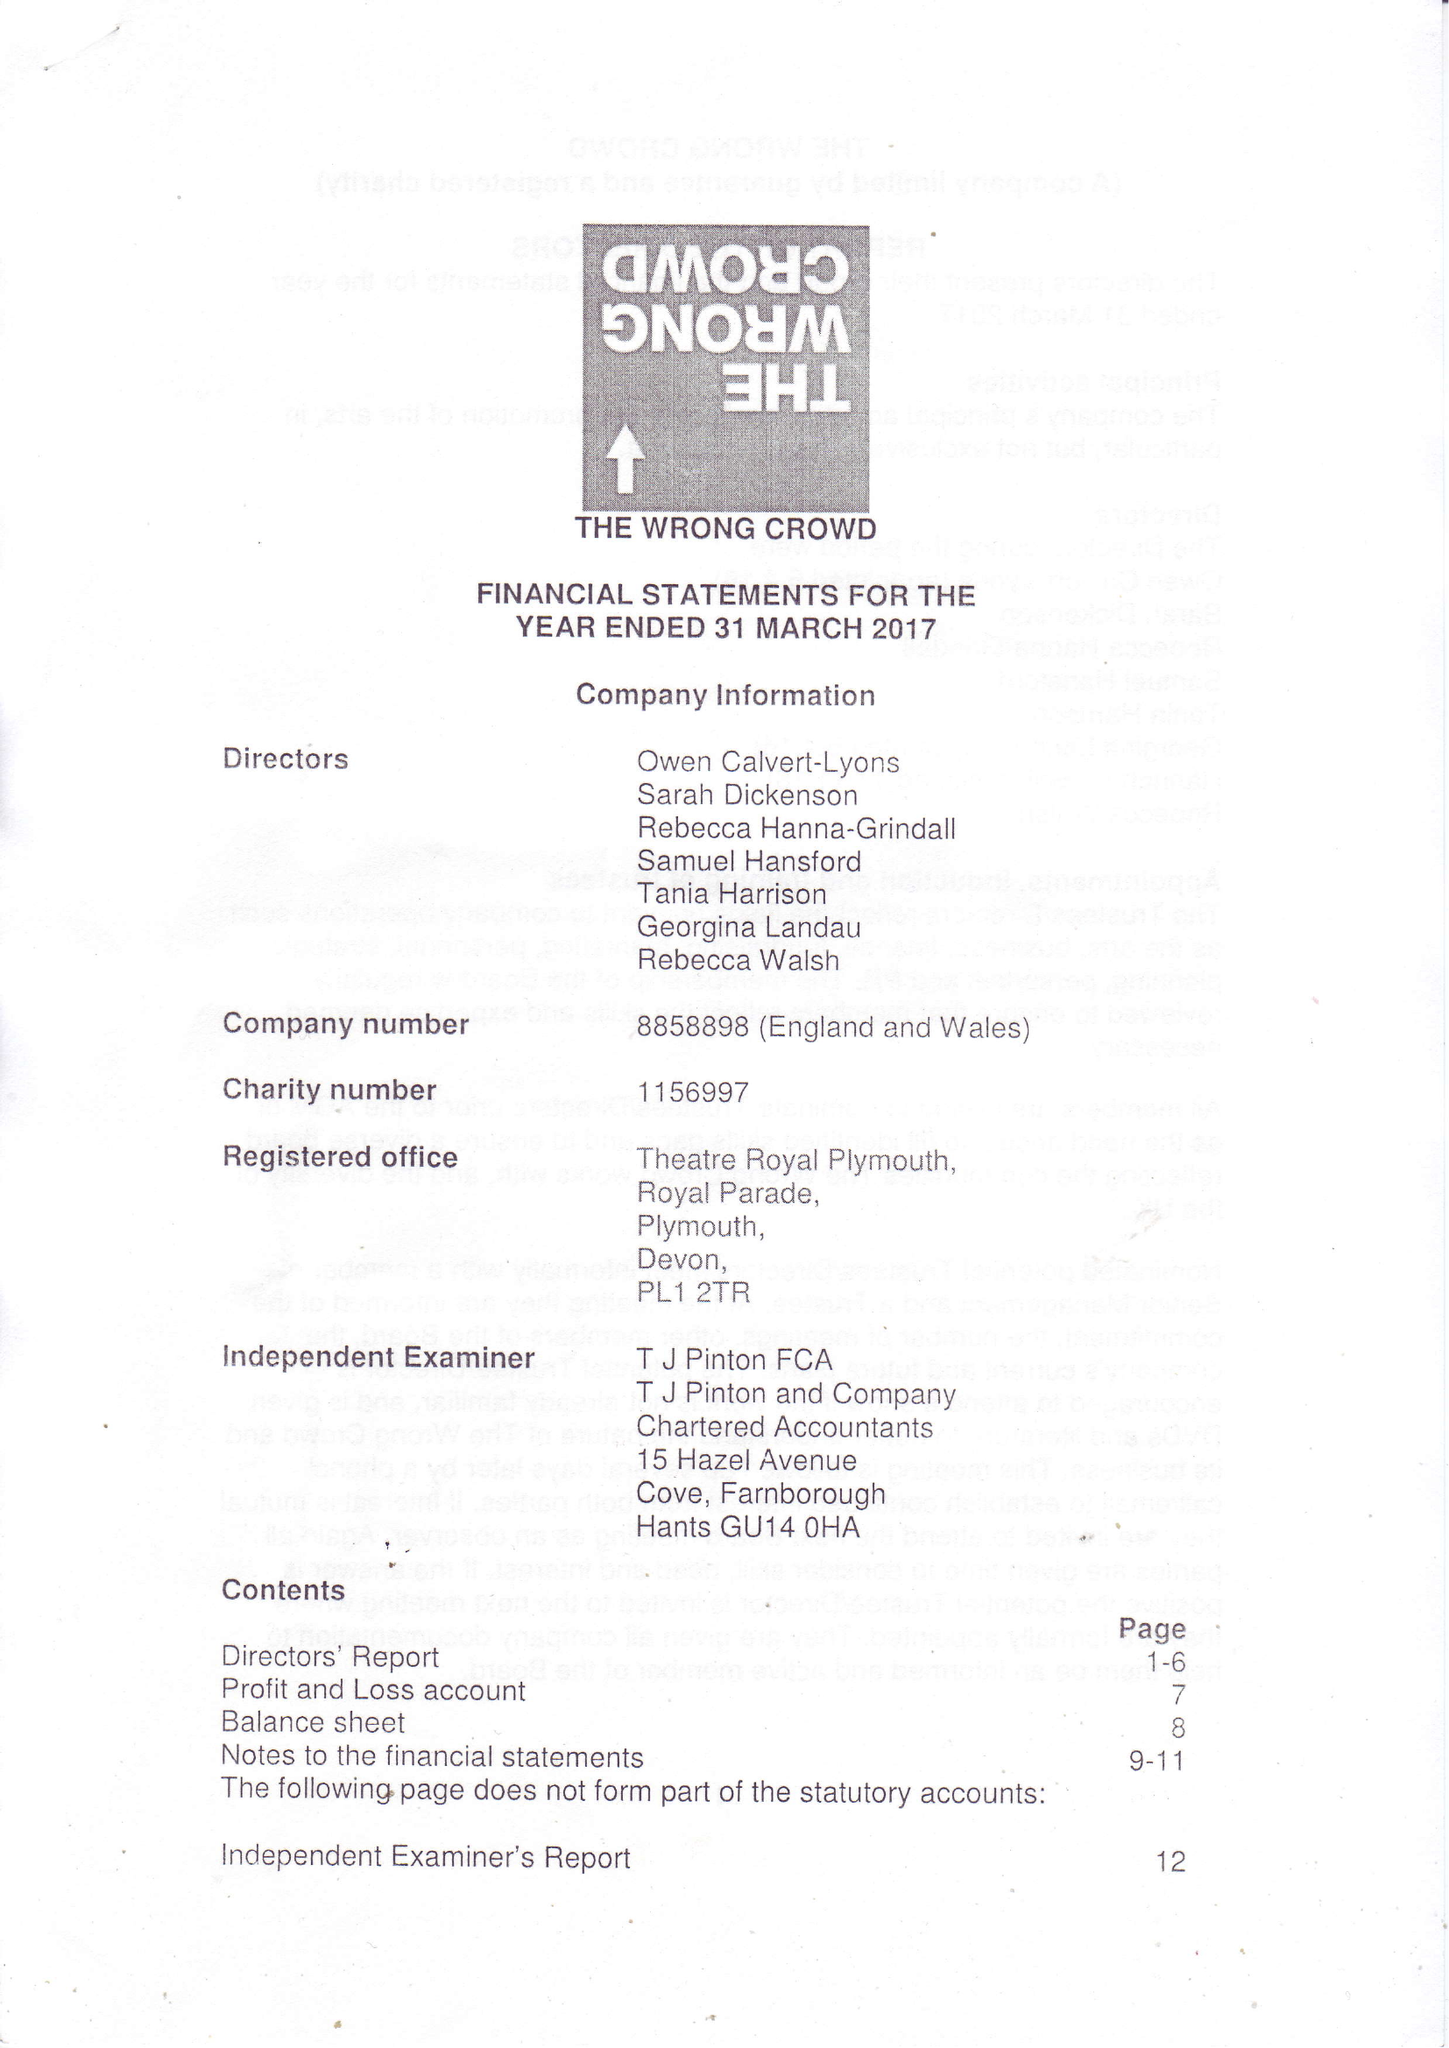What is the value for the spending_annually_in_british_pounds?
Answer the question using a single word or phrase. 62930.00 